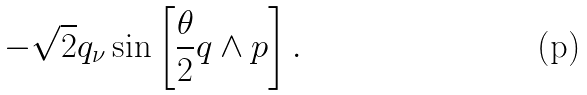Convert formula to latex. <formula><loc_0><loc_0><loc_500><loc_500>- \sqrt { 2 } q _ { \nu } \sin \left [ { \frac { \theta } { 2 } q \wedge p } \right ] .</formula> 